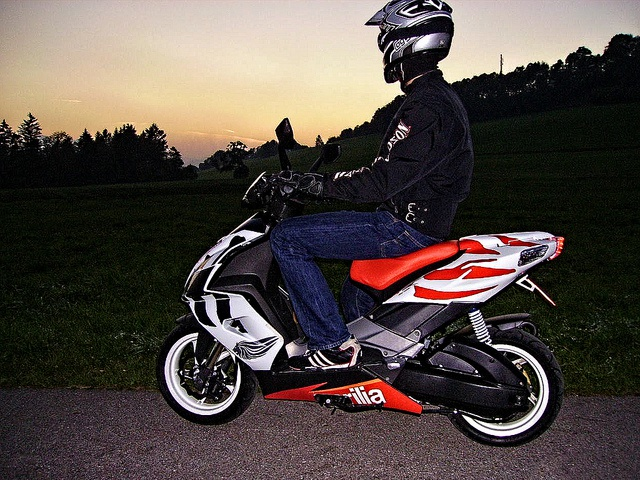Describe the objects in this image and their specific colors. I can see motorcycle in gray, black, lavender, and red tones and people in gray, black, navy, and white tones in this image. 